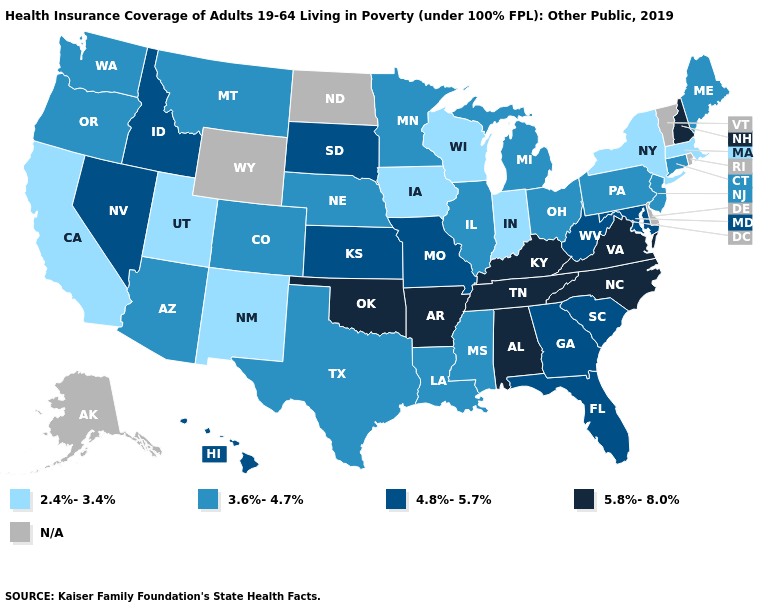Name the states that have a value in the range N/A?
Quick response, please. Alaska, Delaware, North Dakota, Rhode Island, Vermont, Wyoming. Does the map have missing data?
Be succinct. Yes. Does New Mexico have the highest value in the West?
Be succinct. No. Among the states that border North Dakota , does South Dakota have the highest value?
Quick response, please. Yes. Name the states that have a value in the range 3.6%-4.7%?
Keep it brief. Arizona, Colorado, Connecticut, Illinois, Louisiana, Maine, Michigan, Minnesota, Mississippi, Montana, Nebraska, New Jersey, Ohio, Oregon, Pennsylvania, Texas, Washington. Which states hav the highest value in the West?
Quick response, please. Hawaii, Idaho, Nevada. Which states have the lowest value in the USA?
Concise answer only. California, Indiana, Iowa, Massachusetts, New Mexico, New York, Utah, Wisconsin. Name the states that have a value in the range 2.4%-3.4%?
Keep it brief. California, Indiana, Iowa, Massachusetts, New Mexico, New York, Utah, Wisconsin. Name the states that have a value in the range N/A?
Write a very short answer. Alaska, Delaware, North Dakota, Rhode Island, Vermont, Wyoming. What is the highest value in states that border Louisiana?
Answer briefly. 5.8%-8.0%. Does California have the lowest value in the USA?
Answer briefly. Yes. What is the highest value in the USA?
Short answer required. 5.8%-8.0%. Does Minnesota have the highest value in the USA?
Concise answer only. No. What is the lowest value in the USA?
Quick response, please. 2.4%-3.4%. 